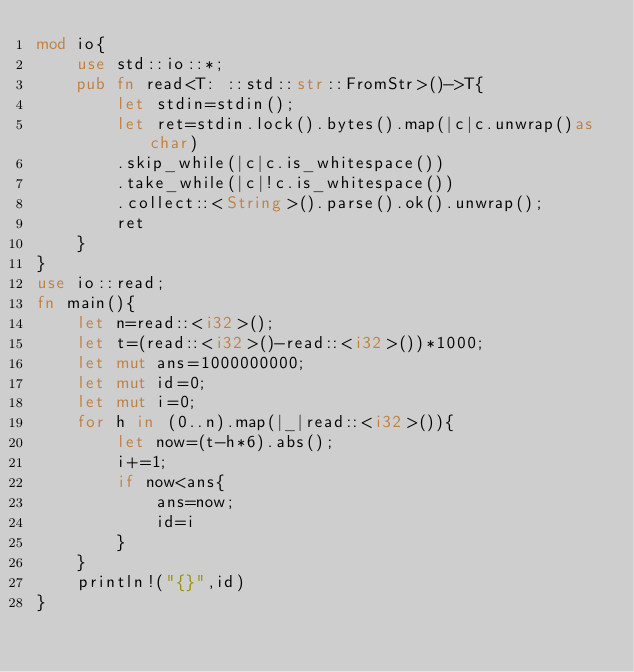Convert code to text. <code><loc_0><loc_0><loc_500><loc_500><_Rust_>mod io{
    use std::io::*;
    pub fn read<T: ::std::str::FromStr>()->T{
        let stdin=stdin();
        let ret=stdin.lock().bytes().map(|c|c.unwrap()as char)
        .skip_while(|c|c.is_whitespace())
        .take_while(|c|!c.is_whitespace())
        .collect::<String>().parse().ok().unwrap();
        ret
    }
}
use io::read;
fn main(){
    let n=read::<i32>();
    let t=(read::<i32>()-read::<i32>())*1000;
    let mut ans=1000000000;
    let mut id=0;
    let mut i=0;
    for h in (0..n).map(|_|read::<i32>()){
        let now=(t-h*6).abs();
        i+=1;
        if now<ans{
            ans=now;
            id=i
        }
    }
    println!("{}",id)
}
</code> 